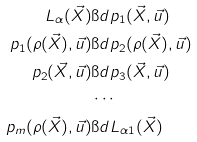<formula> <loc_0><loc_0><loc_500><loc_500>L _ { \alpha } ( \vec { X } ) & \i d p _ { 1 } ( \vec { X } , \vec { u } ) \\ p _ { 1 } ( \rho ( \vec { X } ) , \vec { u } ) & \i d p _ { 2 } ( \rho ( \vec { X } ) , \vec { u } ) \\ p _ { 2 } ( \vec { X } , \vec { u } ) & \i d p _ { 3 } ( \vec { X } , \vec { u } ) \\ & \cdots \\ p _ { m } ( \rho ( \vec { X } ) , \vec { u } ) & \i d L _ { \alpha 1 } ( \vec { X } )</formula> 